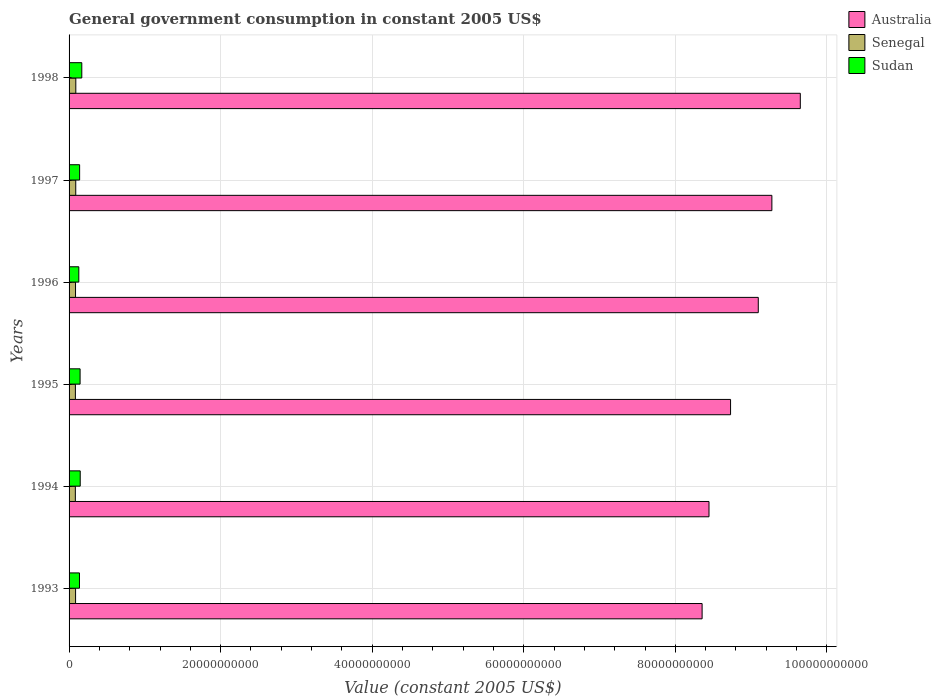How many different coloured bars are there?
Give a very brief answer. 3. Are the number of bars per tick equal to the number of legend labels?
Ensure brevity in your answer.  Yes. How many bars are there on the 5th tick from the bottom?
Provide a short and direct response. 3. What is the label of the 1st group of bars from the top?
Your answer should be compact. 1998. What is the government conusmption in Sudan in 1998?
Your response must be concise. 1.68e+09. Across all years, what is the maximum government conusmption in Sudan?
Keep it short and to the point. 1.68e+09. Across all years, what is the minimum government conusmption in Sudan?
Provide a short and direct response. 1.29e+09. In which year was the government conusmption in Australia minimum?
Your answer should be compact. 1993. What is the total government conusmption in Senegal in the graph?
Make the answer very short. 5.14e+09. What is the difference between the government conusmption in Senegal in 1993 and that in 1997?
Give a very brief answer. -2.12e+07. What is the difference between the government conusmption in Senegal in 1996 and the government conusmption in Sudan in 1998?
Keep it short and to the point. -8.27e+08. What is the average government conusmption in Senegal per year?
Offer a very short reply. 8.57e+08. In the year 1997, what is the difference between the government conusmption in Sudan and government conusmption in Senegal?
Give a very brief answer. 5.13e+08. What is the ratio of the government conusmption in Australia in 1993 to that in 1995?
Make the answer very short. 0.96. What is the difference between the highest and the second highest government conusmption in Australia?
Give a very brief answer. 3.75e+09. What is the difference between the highest and the lowest government conusmption in Senegal?
Offer a terse response. 6.14e+07. Is the sum of the government conusmption in Senegal in 1994 and 1996 greater than the maximum government conusmption in Sudan across all years?
Your answer should be very brief. Yes. What does the 1st bar from the top in 1997 represents?
Offer a very short reply. Sudan. What is the difference between two consecutive major ticks on the X-axis?
Make the answer very short. 2.00e+1. Are the values on the major ticks of X-axis written in scientific E-notation?
Make the answer very short. No. Does the graph contain any zero values?
Ensure brevity in your answer.  No. What is the title of the graph?
Offer a terse response. General government consumption in constant 2005 US$. What is the label or title of the X-axis?
Offer a very short reply. Value (constant 2005 US$). What is the label or title of the Y-axis?
Provide a short and direct response. Years. What is the Value (constant 2005 US$) of Australia in 1993?
Offer a terse response. 8.35e+1. What is the Value (constant 2005 US$) in Senegal in 1993?
Offer a terse response. 8.59e+08. What is the Value (constant 2005 US$) of Sudan in 1993?
Keep it short and to the point. 1.37e+09. What is the Value (constant 2005 US$) in Australia in 1994?
Offer a very short reply. 8.44e+1. What is the Value (constant 2005 US$) in Senegal in 1994?
Your answer should be compact. 8.28e+08. What is the Value (constant 2005 US$) in Sudan in 1994?
Your answer should be compact. 1.47e+09. What is the Value (constant 2005 US$) in Australia in 1995?
Keep it short and to the point. 8.73e+1. What is the Value (constant 2005 US$) of Senegal in 1995?
Provide a succinct answer. 8.34e+08. What is the Value (constant 2005 US$) of Sudan in 1995?
Give a very brief answer. 1.45e+09. What is the Value (constant 2005 US$) of Australia in 1996?
Offer a very short reply. 9.09e+1. What is the Value (constant 2005 US$) of Senegal in 1996?
Keep it short and to the point. 8.52e+08. What is the Value (constant 2005 US$) in Sudan in 1996?
Keep it short and to the point. 1.29e+09. What is the Value (constant 2005 US$) of Australia in 1997?
Offer a terse response. 9.27e+1. What is the Value (constant 2005 US$) of Senegal in 1997?
Keep it short and to the point. 8.80e+08. What is the Value (constant 2005 US$) of Sudan in 1997?
Ensure brevity in your answer.  1.39e+09. What is the Value (constant 2005 US$) in Australia in 1998?
Ensure brevity in your answer.  9.65e+1. What is the Value (constant 2005 US$) in Senegal in 1998?
Provide a short and direct response. 8.89e+08. What is the Value (constant 2005 US$) of Sudan in 1998?
Give a very brief answer. 1.68e+09. Across all years, what is the maximum Value (constant 2005 US$) of Australia?
Your response must be concise. 9.65e+1. Across all years, what is the maximum Value (constant 2005 US$) of Senegal?
Your response must be concise. 8.89e+08. Across all years, what is the maximum Value (constant 2005 US$) of Sudan?
Offer a terse response. 1.68e+09. Across all years, what is the minimum Value (constant 2005 US$) of Australia?
Keep it short and to the point. 8.35e+1. Across all years, what is the minimum Value (constant 2005 US$) of Senegal?
Offer a very short reply. 8.28e+08. Across all years, what is the minimum Value (constant 2005 US$) of Sudan?
Ensure brevity in your answer.  1.29e+09. What is the total Value (constant 2005 US$) in Australia in the graph?
Make the answer very short. 5.35e+11. What is the total Value (constant 2005 US$) of Senegal in the graph?
Keep it short and to the point. 5.14e+09. What is the total Value (constant 2005 US$) in Sudan in the graph?
Your answer should be very brief. 8.66e+09. What is the difference between the Value (constant 2005 US$) in Australia in 1993 and that in 1994?
Offer a very short reply. -9.08e+08. What is the difference between the Value (constant 2005 US$) in Senegal in 1993 and that in 1994?
Offer a very short reply. 3.16e+07. What is the difference between the Value (constant 2005 US$) in Sudan in 1993 and that in 1994?
Provide a short and direct response. -9.91e+07. What is the difference between the Value (constant 2005 US$) of Australia in 1993 and that in 1995?
Your answer should be very brief. -3.75e+09. What is the difference between the Value (constant 2005 US$) in Senegal in 1993 and that in 1995?
Offer a terse response. 2.50e+07. What is the difference between the Value (constant 2005 US$) of Sudan in 1993 and that in 1995?
Provide a short and direct response. -8.08e+07. What is the difference between the Value (constant 2005 US$) in Australia in 1993 and that in 1996?
Your response must be concise. -7.41e+09. What is the difference between the Value (constant 2005 US$) of Senegal in 1993 and that in 1996?
Offer a very short reply. 7.32e+06. What is the difference between the Value (constant 2005 US$) of Sudan in 1993 and that in 1996?
Provide a short and direct response. 8.73e+07. What is the difference between the Value (constant 2005 US$) of Australia in 1993 and that in 1997?
Provide a succinct answer. -9.21e+09. What is the difference between the Value (constant 2005 US$) in Senegal in 1993 and that in 1997?
Your answer should be compact. -2.12e+07. What is the difference between the Value (constant 2005 US$) of Sudan in 1993 and that in 1997?
Your answer should be very brief. -2.10e+07. What is the difference between the Value (constant 2005 US$) in Australia in 1993 and that in 1998?
Offer a very short reply. -1.30e+1. What is the difference between the Value (constant 2005 US$) of Senegal in 1993 and that in 1998?
Provide a short and direct response. -2.98e+07. What is the difference between the Value (constant 2005 US$) in Sudan in 1993 and that in 1998?
Provide a short and direct response. -3.06e+08. What is the difference between the Value (constant 2005 US$) in Australia in 1994 and that in 1995?
Make the answer very short. -2.85e+09. What is the difference between the Value (constant 2005 US$) of Senegal in 1994 and that in 1995?
Offer a very short reply. -6.63e+06. What is the difference between the Value (constant 2005 US$) of Sudan in 1994 and that in 1995?
Your answer should be very brief. 1.82e+07. What is the difference between the Value (constant 2005 US$) of Australia in 1994 and that in 1996?
Ensure brevity in your answer.  -6.50e+09. What is the difference between the Value (constant 2005 US$) in Senegal in 1994 and that in 1996?
Offer a very short reply. -2.43e+07. What is the difference between the Value (constant 2005 US$) of Sudan in 1994 and that in 1996?
Make the answer very short. 1.86e+08. What is the difference between the Value (constant 2005 US$) in Australia in 1994 and that in 1997?
Offer a terse response. -8.30e+09. What is the difference between the Value (constant 2005 US$) in Senegal in 1994 and that in 1997?
Your answer should be compact. -5.28e+07. What is the difference between the Value (constant 2005 US$) of Sudan in 1994 and that in 1997?
Your answer should be very brief. 7.81e+07. What is the difference between the Value (constant 2005 US$) in Australia in 1994 and that in 1998?
Offer a terse response. -1.20e+1. What is the difference between the Value (constant 2005 US$) of Senegal in 1994 and that in 1998?
Ensure brevity in your answer.  -6.14e+07. What is the difference between the Value (constant 2005 US$) in Sudan in 1994 and that in 1998?
Offer a very short reply. -2.07e+08. What is the difference between the Value (constant 2005 US$) in Australia in 1995 and that in 1996?
Keep it short and to the point. -3.66e+09. What is the difference between the Value (constant 2005 US$) in Senegal in 1995 and that in 1996?
Provide a short and direct response. -1.76e+07. What is the difference between the Value (constant 2005 US$) of Sudan in 1995 and that in 1996?
Your response must be concise. 1.68e+08. What is the difference between the Value (constant 2005 US$) of Australia in 1995 and that in 1997?
Keep it short and to the point. -5.45e+09. What is the difference between the Value (constant 2005 US$) of Senegal in 1995 and that in 1997?
Keep it short and to the point. -4.61e+07. What is the difference between the Value (constant 2005 US$) in Sudan in 1995 and that in 1997?
Keep it short and to the point. 5.98e+07. What is the difference between the Value (constant 2005 US$) in Australia in 1995 and that in 1998?
Provide a short and direct response. -9.20e+09. What is the difference between the Value (constant 2005 US$) in Senegal in 1995 and that in 1998?
Ensure brevity in your answer.  -5.48e+07. What is the difference between the Value (constant 2005 US$) in Sudan in 1995 and that in 1998?
Your response must be concise. -2.25e+08. What is the difference between the Value (constant 2005 US$) of Australia in 1996 and that in 1997?
Ensure brevity in your answer.  -1.79e+09. What is the difference between the Value (constant 2005 US$) of Senegal in 1996 and that in 1997?
Provide a succinct answer. -2.85e+07. What is the difference between the Value (constant 2005 US$) of Sudan in 1996 and that in 1997?
Keep it short and to the point. -1.08e+08. What is the difference between the Value (constant 2005 US$) of Australia in 1996 and that in 1998?
Offer a very short reply. -5.55e+09. What is the difference between the Value (constant 2005 US$) in Senegal in 1996 and that in 1998?
Ensure brevity in your answer.  -3.72e+07. What is the difference between the Value (constant 2005 US$) in Sudan in 1996 and that in 1998?
Your response must be concise. -3.93e+08. What is the difference between the Value (constant 2005 US$) in Australia in 1997 and that in 1998?
Give a very brief answer. -3.75e+09. What is the difference between the Value (constant 2005 US$) in Senegal in 1997 and that in 1998?
Your answer should be compact. -8.65e+06. What is the difference between the Value (constant 2005 US$) of Sudan in 1997 and that in 1998?
Ensure brevity in your answer.  -2.85e+08. What is the difference between the Value (constant 2005 US$) in Australia in 1993 and the Value (constant 2005 US$) in Senegal in 1994?
Make the answer very short. 8.27e+1. What is the difference between the Value (constant 2005 US$) in Australia in 1993 and the Value (constant 2005 US$) in Sudan in 1994?
Your answer should be very brief. 8.21e+1. What is the difference between the Value (constant 2005 US$) in Senegal in 1993 and the Value (constant 2005 US$) in Sudan in 1994?
Your answer should be compact. -6.13e+08. What is the difference between the Value (constant 2005 US$) of Australia in 1993 and the Value (constant 2005 US$) of Senegal in 1995?
Offer a very short reply. 8.27e+1. What is the difference between the Value (constant 2005 US$) in Australia in 1993 and the Value (constant 2005 US$) in Sudan in 1995?
Offer a terse response. 8.21e+1. What is the difference between the Value (constant 2005 US$) in Senegal in 1993 and the Value (constant 2005 US$) in Sudan in 1995?
Your answer should be very brief. -5.94e+08. What is the difference between the Value (constant 2005 US$) of Australia in 1993 and the Value (constant 2005 US$) of Senegal in 1996?
Provide a short and direct response. 8.27e+1. What is the difference between the Value (constant 2005 US$) of Australia in 1993 and the Value (constant 2005 US$) of Sudan in 1996?
Offer a terse response. 8.22e+1. What is the difference between the Value (constant 2005 US$) of Senegal in 1993 and the Value (constant 2005 US$) of Sudan in 1996?
Your answer should be compact. -4.26e+08. What is the difference between the Value (constant 2005 US$) of Australia in 1993 and the Value (constant 2005 US$) of Senegal in 1997?
Keep it short and to the point. 8.27e+1. What is the difference between the Value (constant 2005 US$) in Australia in 1993 and the Value (constant 2005 US$) in Sudan in 1997?
Your answer should be very brief. 8.21e+1. What is the difference between the Value (constant 2005 US$) in Senegal in 1993 and the Value (constant 2005 US$) in Sudan in 1997?
Make the answer very short. -5.34e+08. What is the difference between the Value (constant 2005 US$) of Australia in 1993 and the Value (constant 2005 US$) of Senegal in 1998?
Provide a succinct answer. 8.26e+1. What is the difference between the Value (constant 2005 US$) in Australia in 1993 and the Value (constant 2005 US$) in Sudan in 1998?
Your answer should be very brief. 8.19e+1. What is the difference between the Value (constant 2005 US$) of Senegal in 1993 and the Value (constant 2005 US$) of Sudan in 1998?
Ensure brevity in your answer.  -8.19e+08. What is the difference between the Value (constant 2005 US$) in Australia in 1994 and the Value (constant 2005 US$) in Senegal in 1995?
Keep it short and to the point. 8.36e+1. What is the difference between the Value (constant 2005 US$) of Australia in 1994 and the Value (constant 2005 US$) of Sudan in 1995?
Provide a succinct answer. 8.30e+1. What is the difference between the Value (constant 2005 US$) in Senegal in 1994 and the Value (constant 2005 US$) in Sudan in 1995?
Your response must be concise. -6.26e+08. What is the difference between the Value (constant 2005 US$) in Australia in 1994 and the Value (constant 2005 US$) in Senegal in 1996?
Your answer should be very brief. 8.36e+1. What is the difference between the Value (constant 2005 US$) of Australia in 1994 and the Value (constant 2005 US$) of Sudan in 1996?
Ensure brevity in your answer.  8.32e+1. What is the difference between the Value (constant 2005 US$) in Senegal in 1994 and the Value (constant 2005 US$) in Sudan in 1996?
Make the answer very short. -4.58e+08. What is the difference between the Value (constant 2005 US$) in Australia in 1994 and the Value (constant 2005 US$) in Senegal in 1997?
Keep it short and to the point. 8.36e+1. What is the difference between the Value (constant 2005 US$) in Australia in 1994 and the Value (constant 2005 US$) in Sudan in 1997?
Offer a very short reply. 8.30e+1. What is the difference between the Value (constant 2005 US$) of Senegal in 1994 and the Value (constant 2005 US$) of Sudan in 1997?
Provide a succinct answer. -5.66e+08. What is the difference between the Value (constant 2005 US$) in Australia in 1994 and the Value (constant 2005 US$) in Senegal in 1998?
Keep it short and to the point. 8.36e+1. What is the difference between the Value (constant 2005 US$) in Australia in 1994 and the Value (constant 2005 US$) in Sudan in 1998?
Offer a very short reply. 8.28e+1. What is the difference between the Value (constant 2005 US$) of Senegal in 1994 and the Value (constant 2005 US$) of Sudan in 1998?
Your answer should be compact. -8.51e+08. What is the difference between the Value (constant 2005 US$) in Australia in 1995 and the Value (constant 2005 US$) in Senegal in 1996?
Keep it short and to the point. 8.64e+1. What is the difference between the Value (constant 2005 US$) in Australia in 1995 and the Value (constant 2005 US$) in Sudan in 1996?
Your answer should be very brief. 8.60e+1. What is the difference between the Value (constant 2005 US$) of Senegal in 1995 and the Value (constant 2005 US$) of Sudan in 1996?
Provide a succinct answer. -4.51e+08. What is the difference between the Value (constant 2005 US$) in Australia in 1995 and the Value (constant 2005 US$) in Senegal in 1997?
Your response must be concise. 8.64e+1. What is the difference between the Value (constant 2005 US$) of Australia in 1995 and the Value (constant 2005 US$) of Sudan in 1997?
Give a very brief answer. 8.59e+1. What is the difference between the Value (constant 2005 US$) of Senegal in 1995 and the Value (constant 2005 US$) of Sudan in 1997?
Keep it short and to the point. -5.59e+08. What is the difference between the Value (constant 2005 US$) of Australia in 1995 and the Value (constant 2005 US$) of Senegal in 1998?
Give a very brief answer. 8.64e+1. What is the difference between the Value (constant 2005 US$) of Australia in 1995 and the Value (constant 2005 US$) of Sudan in 1998?
Your response must be concise. 8.56e+1. What is the difference between the Value (constant 2005 US$) in Senegal in 1995 and the Value (constant 2005 US$) in Sudan in 1998?
Ensure brevity in your answer.  -8.44e+08. What is the difference between the Value (constant 2005 US$) of Australia in 1996 and the Value (constant 2005 US$) of Senegal in 1997?
Your answer should be compact. 9.01e+1. What is the difference between the Value (constant 2005 US$) of Australia in 1996 and the Value (constant 2005 US$) of Sudan in 1997?
Ensure brevity in your answer.  8.96e+1. What is the difference between the Value (constant 2005 US$) of Senegal in 1996 and the Value (constant 2005 US$) of Sudan in 1997?
Offer a terse response. -5.42e+08. What is the difference between the Value (constant 2005 US$) of Australia in 1996 and the Value (constant 2005 US$) of Senegal in 1998?
Offer a very short reply. 9.01e+1. What is the difference between the Value (constant 2005 US$) in Australia in 1996 and the Value (constant 2005 US$) in Sudan in 1998?
Your answer should be compact. 8.93e+1. What is the difference between the Value (constant 2005 US$) in Senegal in 1996 and the Value (constant 2005 US$) in Sudan in 1998?
Make the answer very short. -8.27e+08. What is the difference between the Value (constant 2005 US$) of Australia in 1997 and the Value (constant 2005 US$) of Senegal in 1998?
Make the answer very short. 9.19e+1. What is the difference between the Value (constant 2005 US$) in Australia in 1997 and the Value (constant 2005 US$) in Sudan in 1998?
Give a very brief answer. 9.11e+1. What is the difference between the Value (constant 2005 US$) of Senegal in 1997 and the Value (constant 2005 US$) of Sudan in 1998?
Provide a succinct answer. -7.98e+08. What is the average Value (constant 2005 US$) in Australia per year?
Provide a succinct answer. 8.92e+1. What is the average Value (constant 2005 US$) in Senegal per year?
Offer a very short reply. 8.57e+08. What is the average Value (constant 2005 US$) in Sudan per year?
Your answer should be very brief. 1.44e+09. In the year 1993, what is the difference between the Value (constant 2005 US$) in Australia and Value (constant 2005 US$) in Senegal?
Your answer should be very brief. 8.27e+1. In the year 1993, what is the difference between the Value (constant 2005 US$) of Australia and Value (constant 2005 US$) of Sudan?
Ensure brevity in your answer.  8.22e+1. In the year 1993, what is the difference between the Value (constant 2005 US$) in Senegal and Value (constant 2005 US$) in Sudan?
Give a very brief answer. -5.13e+08. In the year 1994, what is the difference between the Value (constant 2005 US$) in Australia and Value (constant 2005 US$) in Senegal?
Provide a succinct answer. 8.36e+1. In the year 1994, what is the difference between the Value (constant 2005 US$) in Australia and Value (constant 2005 US$) in Sudan?
Ensure brevity in your answer.  8.30e+1. In the year 1994, what is the difference between the Value (constant 2005 US$) in Senegal and Value (constant 2005 US$) in Sudan?
Keep it short and to the point. -6.44e+08. In the year 1995, what is the difference between the Value (constant 2005 US$) of Australia and Value (constant 2005 US$) of Senegal?
Your answer should be compact. 8.65e+1. In the year 1995, what is the difference between the Value (constant 2005 US$) in Australia and Value (constant 2005 US$) in Sudan?
Keep it short and to the point. 8.58e+1. In the year 1995, what is the difference between the Value (constant 2005 US$) in Senegal and Value (constant 2005 US$) in Sudan?
Offer a very short reply. -6.19e+08. In the year 1996, what is the difference between the Value (constant 2005 US$) of Australia and Value (constant 2005 US$) of Senegal?
Keep it short and to the point. 9.01e+1. In the year 1996, what is the difference between the Value (constant 2005 US$) of Australia and Value (constant 2005 US$) of Sudan?
Your answer should be very brief. 8.97e+1. In the year 1996, what is the difference between the Value (constant 2005 US$) of Senegal and Value (constant 2005 US$) of Sudan?
Your answer should be very brief. -4.33e+08. In the year 1997, what is the difference between the Value (constant 2005 US$) in Australia and Value (constant 2005 US$) in Senegal?
Make the answer very short. 9.19e+1. In the year 1997, what is the difference between the Value (constant 2005 US$) in Australia and Value (constant 2005 US$) in Sudan?
Make the answer very short. 9.13e+1. In the year 1997, what is the difference between the Value (constant 2005 US$) of Senegal and Value (constant 2005 US$) of Sudan?
Your answer should be compact. -5.13e+08. In the year 1998, what is the difference between the Value (constant 2005 US$) of Australia and Value (constant 2005 US$) of Senegal?
Keep it short and to the point. 9.56e+1. In the year 1998, what is the difference between the Value (constant 2005 US$) in Australia and Value (constant 2005 US$) in Sudan?
Your response must be concise. 9.48e+1. In the year 1998, what is the difference between the Value (constant 2005 US$) in Senegal and Value (constant 2005 US$) in Sudan?
Make the answer very short. -7.90e+08. What is the ratio of the Value (constant 2005 US$) in Senegal in 1993 to that in 1994?
Provide a succinct answer. 1.04. What is the ratio of the Value (constant 2005 US$) of Sudan in 1993 to that in 1994?
Make the answer very short. 0.93. What is the ratio of the Value (constant 2005 US$) in Senegal in 1993 to that in 1995?
Your answer should be very brief. 1.03. What is the ratio of the Value (constant 2005 US$) in Sudan in 1993 to that in 1995?
Your answer should be compact. 0.94. What is the ratio of the Value (constant 2005 US$) of Australia in 1993 to that in 1996?
Give a very brief answer. 0.92. What is the ratio of the Value (constant 2005 US$) of Senegal in 1993 to that in 1996?
Ensure brevity in your answer.  1.01. What is the ratio of the Value (constant 2005 US$) in Sudan in 1993 to that in 1996?
Your answer should be compact. 1.07. What is the ratio of the Value (constant 2005 US$) in Australia in 1993 to that in 1997?
Your answer should be very brief. 0.9. What is the ratio of the Value (constant 2005 US$) in Senegal in 1993 to that in 1997?
Offer a very short reply. 0.98. What is the ratio of the Value (constant 2005 US$) in Sudan in 1993 to that in 1997?
Your answer should be compact. 0.98. What is the ratio of the Value (constant 2005 US$) in Australia in 1993 to that in 1998?
Your response must be concise. 0.87. What is the ratio of the Value (constant 2005 US$) in Senegal in 1993 to that in 1998?
Your answer should be very brief. 0.97. What is the ratio of the Value (constant 2005 US$) of Sudan in 1993 to that in 1998?
Your answer should be compact. 0.82. What is the ratio of the Value (constant 2005 US$) in Australia in 1994 to that in 1995?
Your response must be concise. 0.97. What is the ratio of the Value (constant 2005 US$) of Senegal in 1994 to that in 1995?
Make the answer very short. 0.99. What is the ratio of the Value (constant 2005 US$) in Sudan in 1994 to that in 1995?
Provide a succinct answer. 1.01. What is the ratio of the Value (constant 2005 US$) of Australia in 1994 to that in 1996?
Your answer should be very brief. 0.93. What is the ratio of the Value (constant 2005 US$) of Senegal in 1994 to that in 1996?
Your response must be concise. 0.97. What is the ratio of the Value (constant 2005 US$) of Sudan in 1994 to that in 1996?
Offer a very short reply. 1.15. What is the ratio of the Value (constant 2005 US$) in Australia in 1994 to that in 1997?
Offer a terse response. 0.91. What is the ratio of the Value (constant 2005 US$) in Senegal in 1994 to that in 1997?
Offer a very short reply. 0.94. What is the ratio of the Value (constant 2005 US$) of Sudan in 1994 to that in 1997?
Your answer should be compact. 1.06. What is the ratio of the Value (constant 2005 US$) in Australia in 1994 to that in 1998?
Offer a very short reply. 0.88. What is the ratio of the Value (constant 2005 US$) in Senegal in 1994 to that in 1998?
Provide a succinct answer. 0.93. What is the ratio of the Value (constant 2005 US$) of Sudan in 1994 to that in 1998?
Ensure brevity in your answer.  0.88. What is the ratio of the Value (constant 2005 US$) in Australia in 1995 to that in 1996?
Give a very brief answer. 0.96. What is the ratio of the Value (constant 2005 US$) of Senegal in 1995 to that in 1996?
Make the answer very short. 0.98. What is the ratio of the Value (constant 2005 US$) of Sudan in 1995 to that in 1996?
Your answer should be very brief. 1.13. What is the ratio of the Value (constant 2005 US$) in Australia in 1995 to that in 1997?
Your answer should be very brief. 0.94. What is the ratio of the Value (constant 2005 US$) in Senegal in 1995 to that in 1997?
Provide a succinct answer. 0.95. What is the ratio of the Value (constant 2005 US$) of Sudan in 1995 to that in 1997?
Your response must be concise. 1.04. What is the ratio of the Value (constant 2005 US$) of Australia in 1995 to that in 1998?
Provide a short and direct response. 0.9. What is the ratio of the Value (constant 2005 US$) in Senegal in 1995 to that in 1998?
Your answer should be very brief. 0.94. What is the ratio of the Value (constant 2005 US$) in Sudan in 1995 to that in 1998?
Your answer should be very brief. 0.87. What is the ratio of the Value (constant 2005 US$) of Australia in 1996 to that in 1997?
Make the answer very short. 0.98. What is the ratio of the Value (constant 2005 US$) of Senegal in 1996 to that in 1997?
Give a very brief answer. 0.97. What is the ratio of the Value (constant 2005 US$) of Sudan in 1996 to that in 1997?
Make the answer very short. 0.92. What is the ratio of the Value (constant 2005 US$) of Australia in 1996 to that in 1998?
Make the answer very short. 0.94. What is the ratio of the Value (constant 2005 US$) of Senegal in 1996 to that in 1998?
Give a very brief answer. 0.96. What is the ratio of the Value (constant 2005 US$) in Sudan in 1996 to that in 1998?
Provide a short and direct response. 0.77. What is the ratio of the Value (constant 2005 US$) in Australia in 1997 to that in 1998?
Provide a short and direct response. 0.96. What is the ratio of the Value (constant 2005 US$) in Senegal in 1997 to that in 1998?
Make the answer very short. 0.99. What is the ratio of the Value (constant 2005 US$) in Sudan in 1997 to that in 1998?
Offer a very short reply. 0.83. What is the difference between the highest and the second highest Value (constant 2005 US$) in Australia?
Offer a very short reply. 3.75e+09. What is the difference between the highest and the second highest Value (constant 2005 US$) in Senegal?
Offer a terse response. 8.65e+06. What is the difference between the highest and the second highest Value (constant 2005 US$) of Sudan?
Your answer should be compact. 2.07e+08. What is the difference between the highest and the lowest Value (constant 2005 US$) in Australia?
Provide a short and direct response. 1.30e+1. What is the difference between the highest and the lowest Value (constant 2005 US$) of Senegal?
Offer a terse response. 6.14e+07. What is the difference between the highest and the lowest Value (constant 2005 US$) of Sudan?
Offer a very short reply. 3.93e+08. 